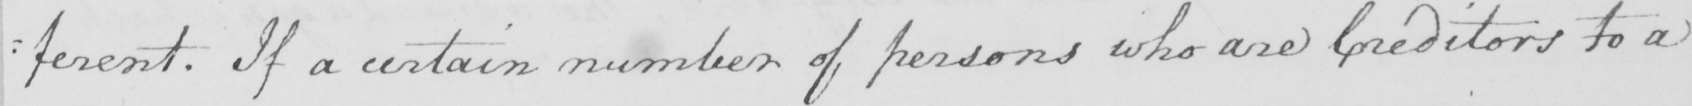What text is written in this handwritten line? : ferent . If a certain number of persons who are Creditors to a 